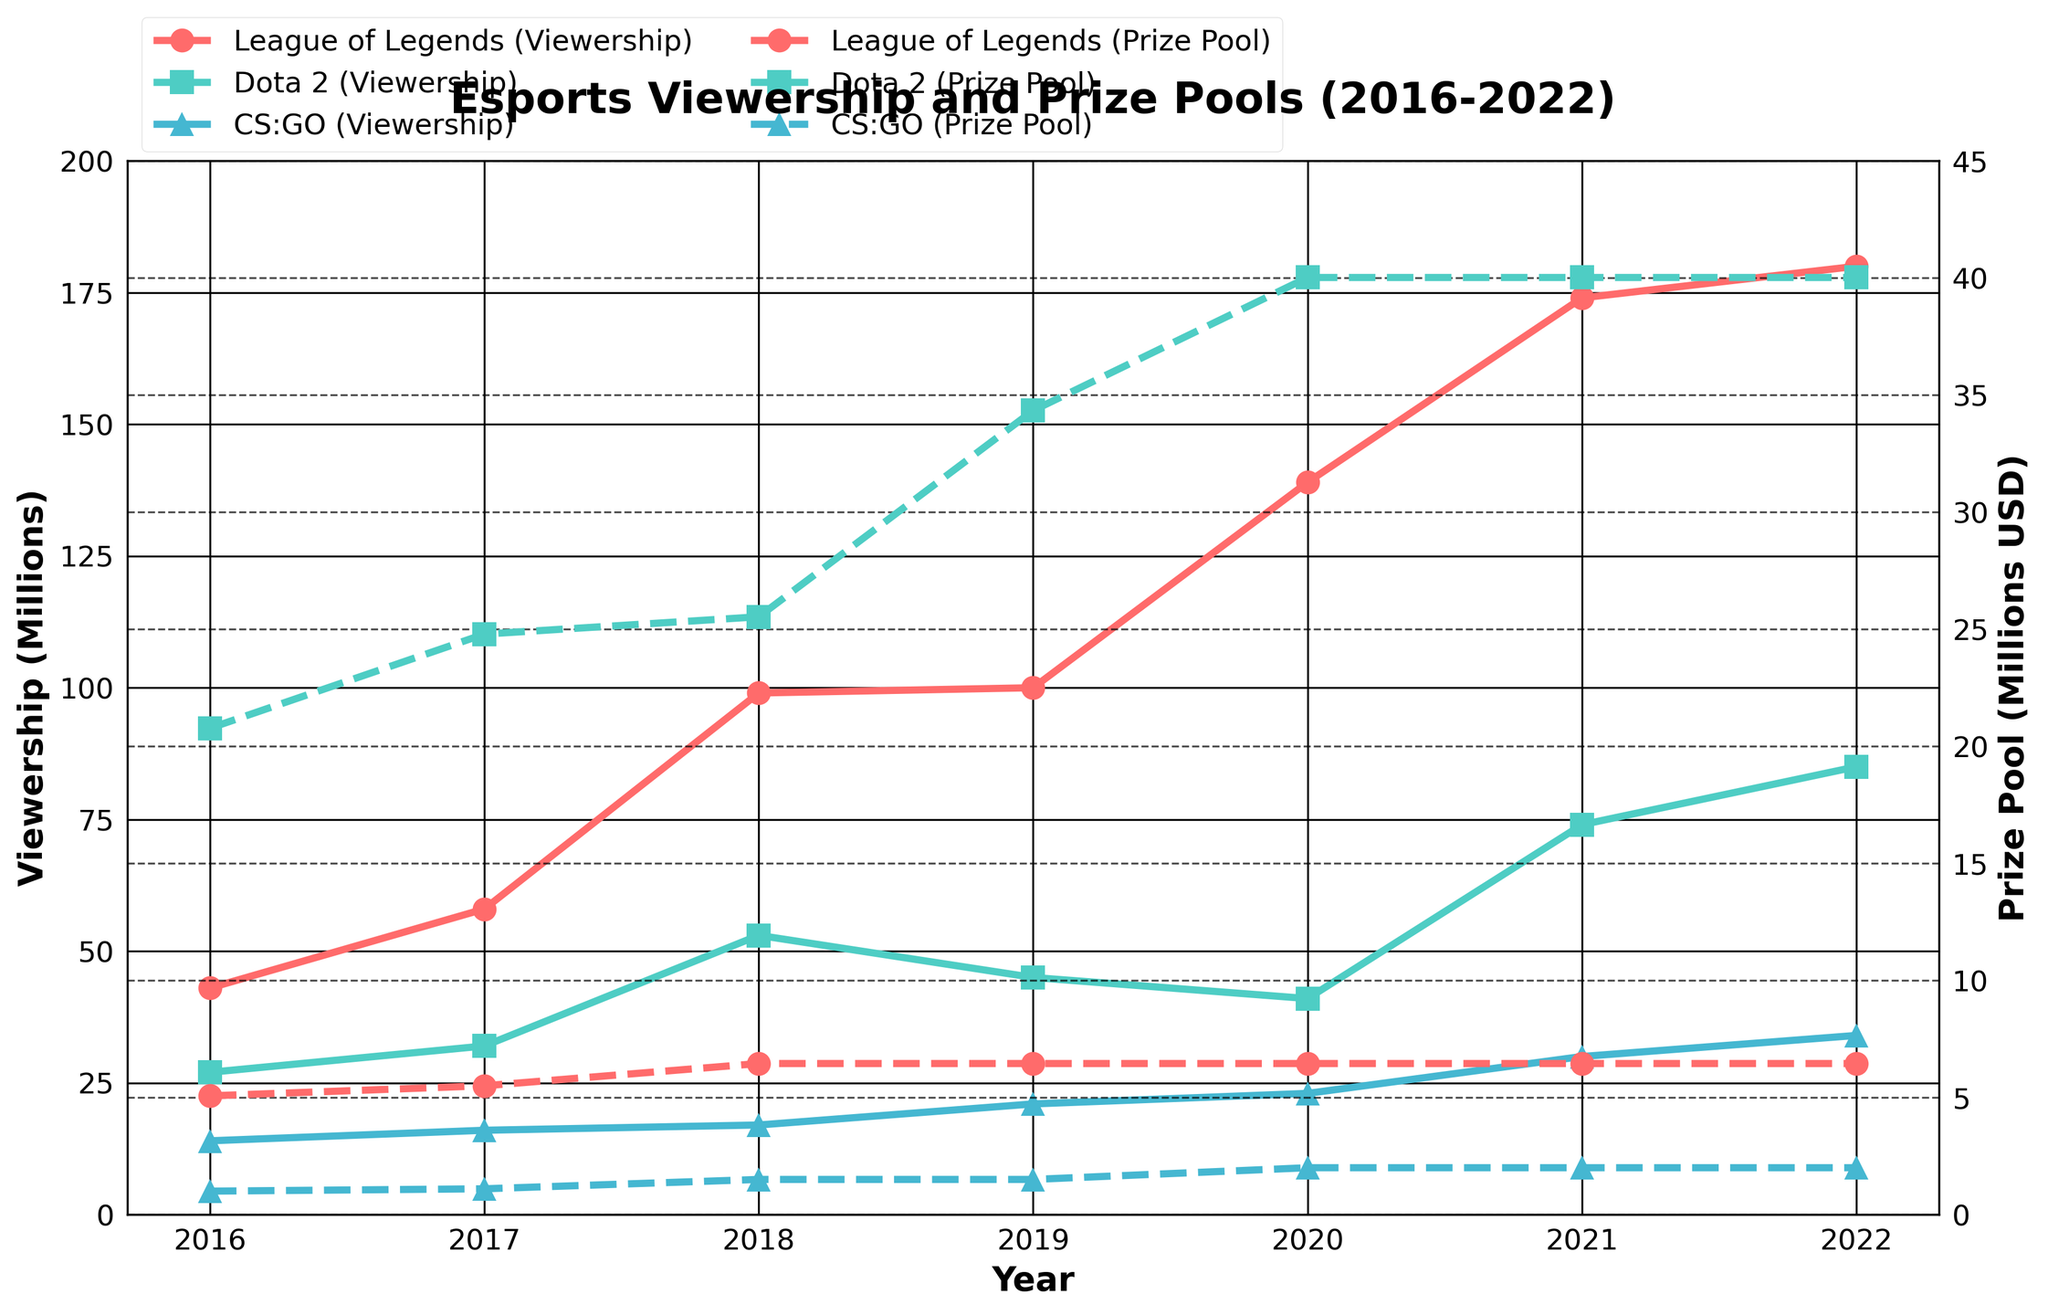What is the title of the figure? The title is usually located at the top of the figure and provides a brief description of what the figure is about. In this case, it indicates that the figure is about Esports viewership and prize pools over the years 2016-2022.
Answer: 'Esports Viewership and Prize Pools (2016-2022)' Which year had the highest League of Legends World Championship viewership? To identify the year with the highest League of Legends World Championship viewership, look at the viewership data points for each year and identify the maximum value. The year with the highest value is the answer.
Answer: 2022 What trend can you observe in CS:GO ESL One Cologne viewership from 2016 to 2022? Observe the viewership data points for CS:GO ESL One Cologne across the years. Notice if the values are increasing, decreasing, or showing some other pattern.
Answer: The viewership shows a general increasing trend Which game had the largest prize pool in 2019 and what was the amount? Check the prize pool values for each game in 2019. Identify the game with the highest value and note the amount.
Answer: Dota 2 with 34.34 million USD Compare the viewership trends of League of Legends and Dota 2 from 2016 to 2022. Which game showed more consistent growth? Examine the viewership lines for League of Legends and Dota 2. Look for the game with a more steady and increasing line trend without significant drops.
Answer: League of Legends What is the maximum prize pool recorded for League of Legends and in which year did it occur? Find the highest prize pool value for League of Legends and identify the corresponding year from the plot.
Answer: 6.45 million USD in 2018 